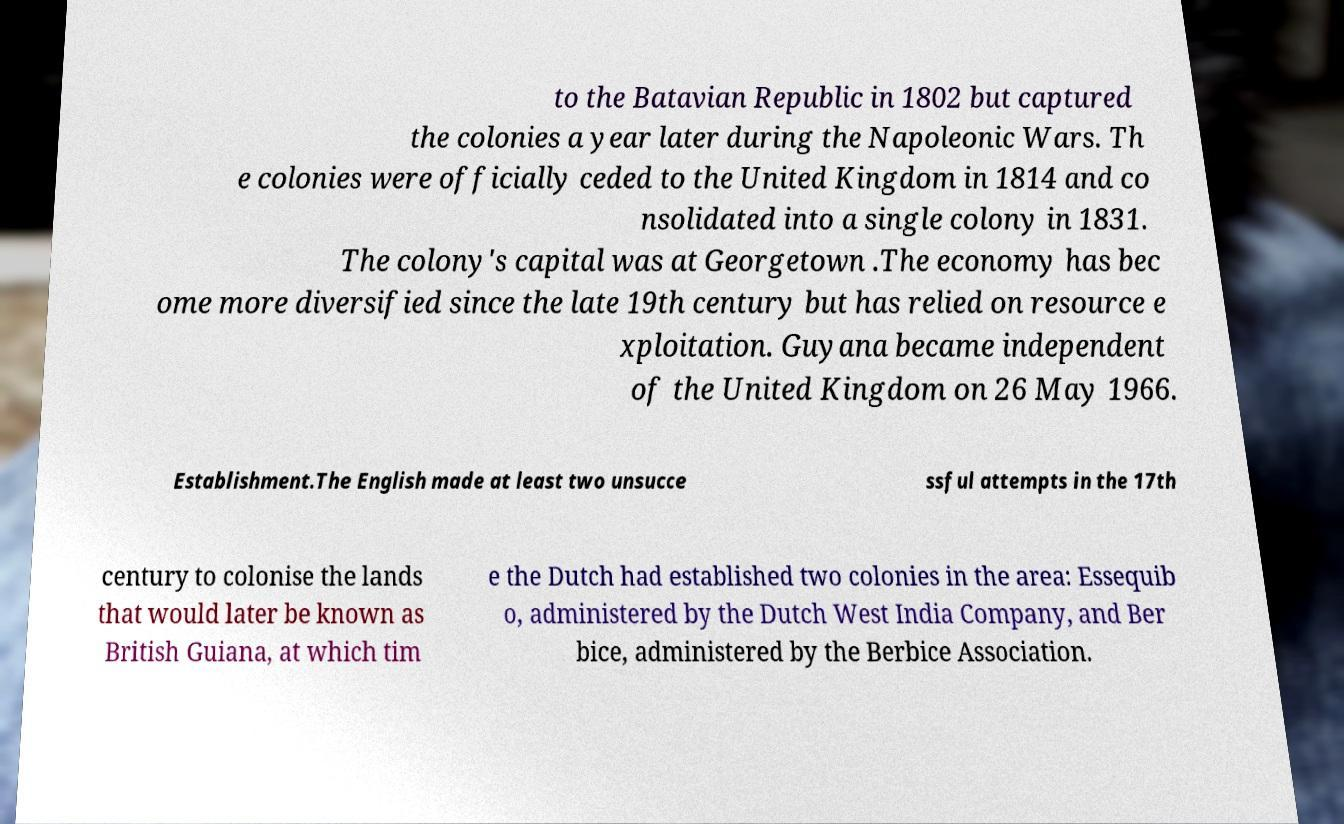Please read and relay the text visible in this image. What does it say? to the Batavian Republic in 1802 but captured the colonies a year later during the Napoleonic Wars. Th e colonies were officially ceded to the United Kingdom in 1814 and co nsolidated into a single colony in 1831. The colony's capital was at Georgetown .The economy has bec ome more diversified since the late 19th century but has relied on resource e xploitation. Guyana became independent of the United Kingdom on 26 May 1966. Establishment.The English made at least two unsucce ssful attempts in the 17th century to colonise the lands that would later be known as British Guiana, at which tim e the Dutch had established two colonies in the area: Essequib o, administered by the Dutch West India Company, and Ber bice, administered by the Berbice Association. 